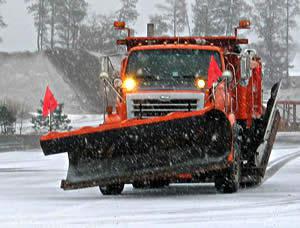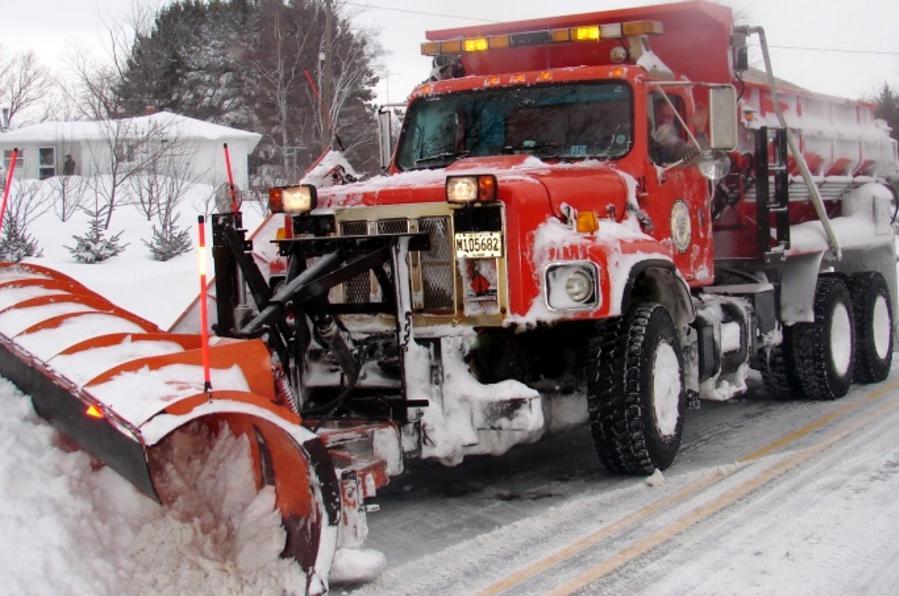The first image is the image on the left, the second image is the image on the right. Analyze the images presented: Is the assertion "The left image shows exactly one commercial snowplow truck facing the camera." valid? Answer yes or no. Yes. The first image is the image on the left, the second image is the image on the right. Analyze the images presented: Is the assertion "There are flags on the plow blade in the image on the left." valid? Answer yes or no. Yes. 